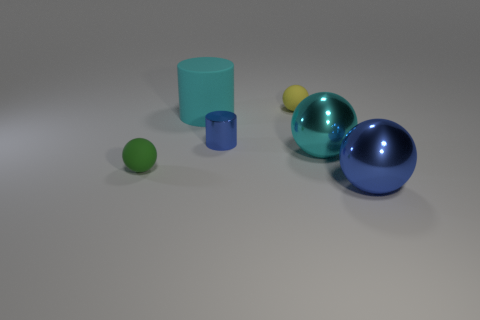What material is the large sphere to the left of the shiny object right of the cyan thing right of the small yellow object?
Offer a terse response. Metal. What number of things are either blue shiny objects or big yellow rubber blocks?
Provide a succinct answer. 2. There is a big thing that is in front of the green thing; does it have the same color as the cylinder that is in front of the large cyan matte thing?
Provide a short and direct response. Yes. What is the shape of the cyan rubber object that is the same size as the blue shiny ball?
Your answer should be very brief. Cylinder. How many things are either matte spheres behind the tiny green rubber sphere or tiny objects behind the big matte object?
Your response must be concise. 1. Is the number of big cyan spheres less than the number of cylinders?
Provide a succinct answer. Yes. What is the material of the blue object that is the same size as the cyan rubber cylinder?
Provide a short and direct response. Metal. Does the rubber sphere behind the shiny cylinder have the same size as the blue object that is behind the green matte object?
Your answer should be compact. Yes. Are there any big cyan things made of the same material as the small yellow thing?
Give a very brief answer. Yes. How many things are either green matte things in front of the small shiny thing or big brown metallic objects?
Offer a very short reply. 1. 